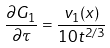Convert formula to latex. <formula><loc_0><loc_0><loc_500><loc_500>\frac { \partial G _ { 1 } } { \partial \tau } = \frac { v _ { 1 } ( x ) } { 1 0 t ^ { 2 / 3 } }</formula> 